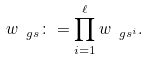<formula> <loc_0><loc_0><loc_500><loc_500>w _ { \ g s } \colon = \prod _ { i = 1 } ^ { \ell } w _ { \ g s ^ { i } } .</formula> 